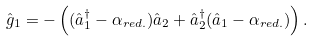Convert formula to latex. <formula><loc_0><loc_0><loc_500><loc_500>\hat { g } _ { 1 } = - \left ( ( \hat { a } _ { 1 } ^ { \dagger } - \alpha _ { r e d . } ) \hat { a } _ { 2 } + \hat { a } _ { 2 } ^ { \dagger } ( \hat { a } _ { 1 } - \alpha _ { r e d . } ) \right ) .</formula> 